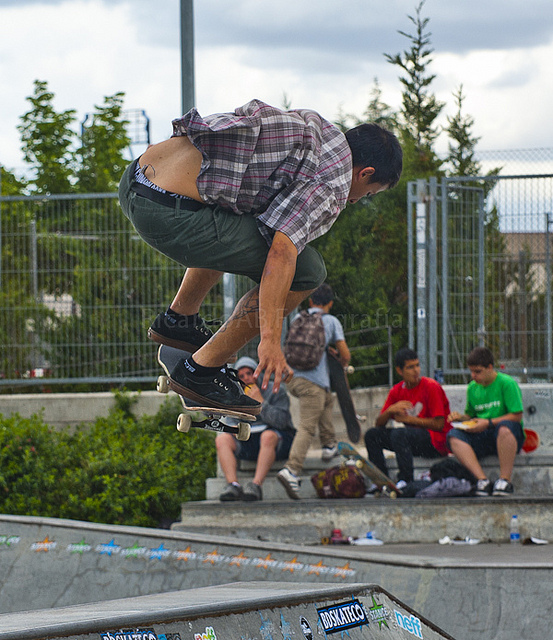Extract all visible text content from this image. BDSKATECO 